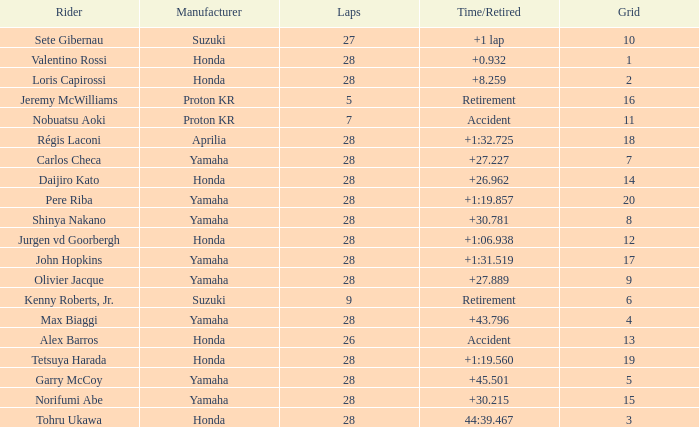How many laps were in grid 4? 28.0. 